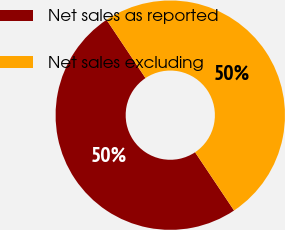<chart> <loc_0><loc_0><loc_500><loc_500><pie_chart><fcel>Net sales as reported<fcel>Net sales excluding<nl><fcel>50.01%<fcel>49.99%<nl></chart> 